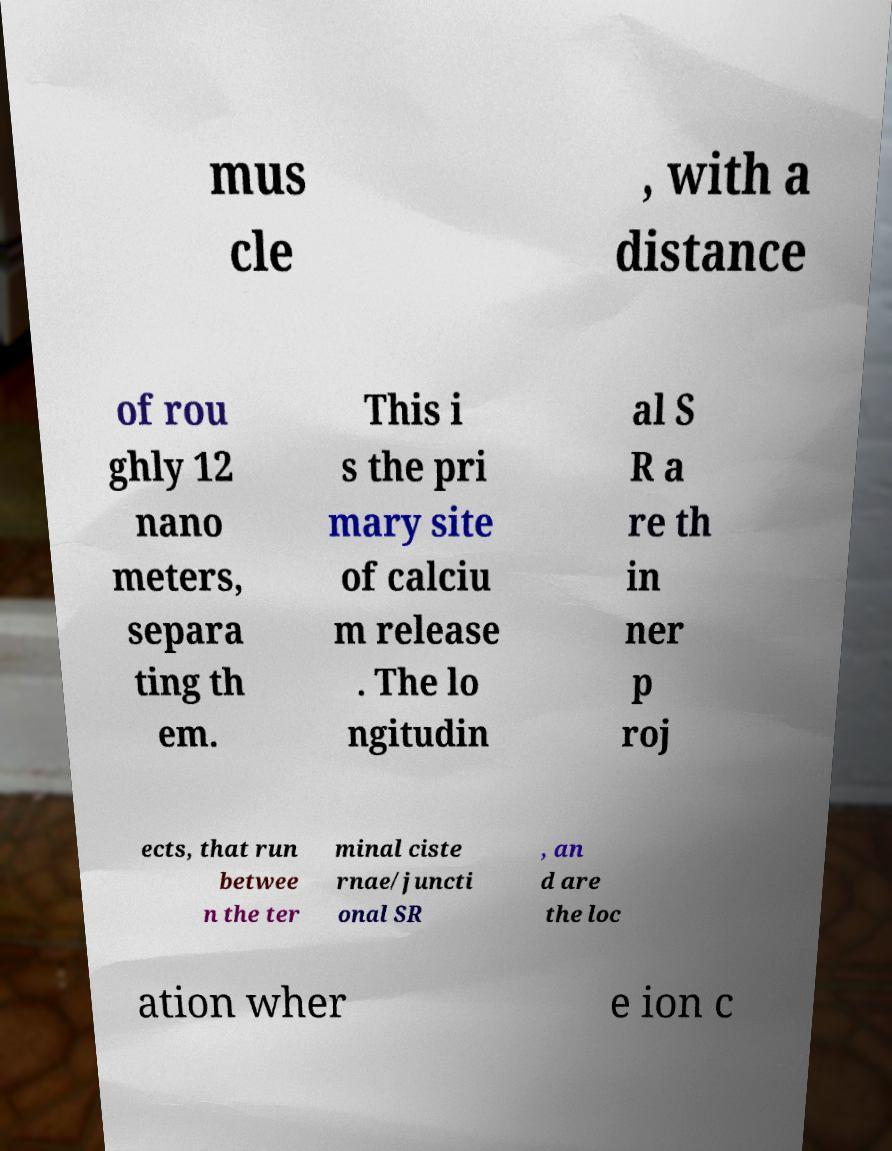Could you assist in decoding the text presented in this image and type it out clearly? mus cle , with a distance of rou ghly 12 nano meters, separa ting th em. This i s the pri mary site of calciu m release . The lo ngitudin al S R a re th in ner p roj ects, that run betwee n the ter minal ciste rnae/juncti onal SR , an d are the loc ation wher e ion c 